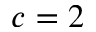<formula> <loc_0><loc_0><loc_500><loc_500>c = 2</formula> 